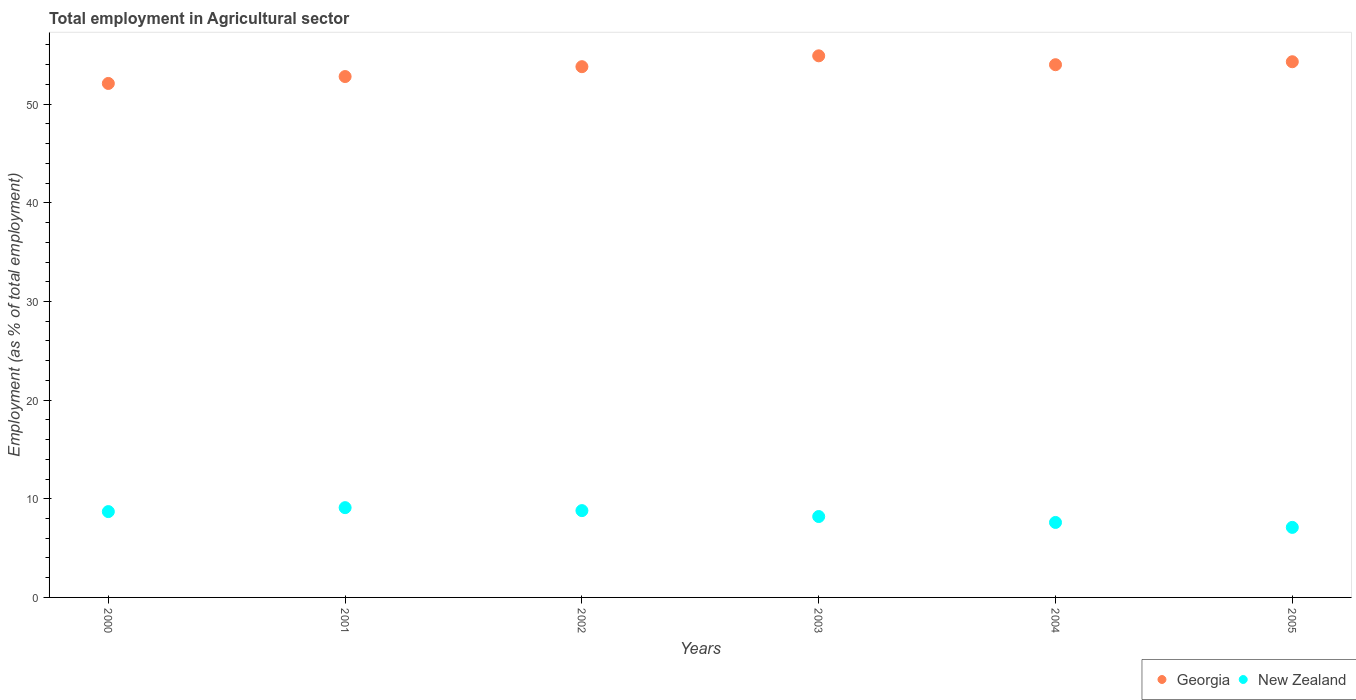How many different coloured dotlines are there?
Offer a very short reply. 2. What is the employment in agricultural sector in Georgia in 2004?
Keep it short and to the point. 54. Across all years, what is the maximum employment in agricultural sector in New Zealand?
Keep it short and to the point. 9.1. Across all years, what is the minimum employment in agricultural sector in Georgia?
Ensure brevity in your answer.  52.1. What is the total employment in agricultural sector in Georgia in the graph?
Your response must be concise. 321.9. What is the difference between the employment in agricultural sector in New Zealand in 2000 and that in 2005?
Make the answer very short. 1.6. What is the difference between the employment in agricultural sector in New Zealand in 2003 and the employment in agricultural sector in Georgia in 2001?
Offer a very short reply. -44.6. What is the average employment in agricultural sector in New Zealand per year?
Provide a succinct answer. 8.25. In the year 2000, what is the difference between the employment in agricultural sector in Georgia and employment in agricultural sector in New Zealand?
Keep it short and to the point. 43.4. What is the ratio of the employment in agricultural sector in New Zealand in 2000 to that in 2005?
Your response must be concise. 1.23. What is the difference between the highest and the second highest employment in agricultural sector in New Zealand?
Provide a succinct answer. 0.3. What is the difference between the highest and the lowest employment in agricultural sector in New Zealand?
Ensure brevity in your answer.  2. In how many years, is the employment in agricultural sector in New Zealand greater than the average employment in agricultural sector in New Zealand taken over all years?
Keep it short and to the point. 3. Is the sum of the employment in agricultural sector in Georgia in 2002 and 2003 greater than the maximum employment in agricultural sector in New Zealand across all years?
Keep it short and to the point. Yes. Does the employment in agricultural sector in Georgia monotonically increase over the years?
Your answer should be very brief. No. Is the employment in agricultural sector in Georgia strictly greater than the employment in agricultural sector in New Zealand over the years?
Ensure brevity in your answer.  Yes. Is the employment in agricultural sector in Georgia strictly less than the employment in agricultural sector in New Zealand over the years?
Keep it short and to the point. No. How many dotlines are there?
Your answer should be compact. 2. What is the difference between two consecutive major ticks on the Y-axis?
Your answer should be very brief. 10. Does the graph contain any zero values?
Make the answer very short. No. How are the legend labels stacked?
Make the answer very short. Horizontal. What is the title of the graph?
Ensure brevity in your answer.  Total employment in Agricultural sector. What is the label or title of the X-axis?
Offer a very short reply. Years. What is the label or title of the Y-axis?
Provide a succinct answer. Employment (as % of total employment). What is the Employment (as % of total employment) in Georgia in 2000?
Your answer should be compact. 52.1. What is the Employment (as % of total employment) of New Zealand in 2000?
Ensure brevity in your answer.  8.7. What is the Employment (as % of total employment) in Georgia in 2001?
Give a very brief answer. 52.8. What is the Employment (as % of total employment) of New Zealand in 2001?
Offer a terse response. 9.1. What is the Employment (as % of total employment) of Georgia in 2002?
Make the answer very short. 53.8. What is the Employment (as % of total employment) in New Zealand in 2002?
Ensure brevity in your answer.  8.8. What is the Employment (as % of total employment) in Georgia in 2003?
Offer a terse response. 54.9. What is the Employment (as % of total employment) of New Zealand in 2003?
Give a very brief answer. 8.2. What is the Employment (as % of total employment) in Georgia in 2004?
Offer a very short reply. 54. What is the Employment (as % of total employment) in New Zealand in 2004?
Your answer should be compact. 7.6. What is the Employment (as % of total employment) of Georgia in 2005?
Provide a short and direct response. 54.3. What is the Employment (as % of total employment) of New Zealand in 2005?
Offer a terse response. 7.1. Across all years, what is the maximum Employment (as % of total employment) in Georgia?
Give a very brief answer. 54.9. Across all years, what is the maximum Employment (as % of total employment) of New Zealand?
Offer a very short reply. 9.1. Across all years, what is the minimum Employment (as % of total employment) in Georgia?
Ensure brevity in your answer.  52.1. Across all years, what is the minimum Employment (as % of total employment) of New Zealand?
Offer a very short reply. 7.1. What is the total Employment (as % of total employment) of Georgia in the graph?
Your answer should be very brief. 321.9. What is the total Employment (as % of total employment) in New Zealand in the graph?
Provide a short and direct response. 49.5. What is the difference between the Employment (as % of total employment) of Georgia in 2000 and that in 2001?
Provide a short and direct response. -0.7. What is the difference between the Employment (as % of total employment) in New Zealand in 2000 and that in 2001?
Your answer should be compact. -0.4. What is the difference between the Employment (as % of total employment) in Georgia in 2000 and that in 2002?
Your response must be concise. -1.7. What is the difference between the Employment (as % of total employment) in Georgia in 2000 and that in 2004?
Ensure brevity in your answer.  -1.9. What is the difference between the Employment (as % of total employment) of New Zealand in 2000 and that in 2004?
Your answer should be compact. 1.1. What is the difference between the Employment (as % of total employment) in Georgia in 2000 and that in 2005?
Ensure brevity in your answer.  -2.2. What is the difference between the Employment (as % of total employment) in Georgia in 2001 and that in 2002?
Provide a succinct answer. -1. What is the difference between the Employment (as % of total employment) in Georgia in 2001 and that in 2003?
Give a very brief answer. -2.1. What is the difference between the Employment (as % of total employment) in New Zealand in 2001 and that in 2005?
Provide a succinct answer. 2. What is the difference between the Employment (as % of total employment) of Georgia in 2002 and that in 2003?
Ensure brevity in your answer.  -1.1. What is the difference between the Employment (as % of total employment) in New Zealand in 2002 and that in 2004?
Offer a very short reply. 1.2. What is the difference between the Employment (as % of total employment) in New Zealand in 2003 and that in 2004?
Keep it short and to the point. 0.6. What is the difference between the Employment (as % of total employment) in Georgia in 2004 and that in 2005?
Give a very brief answer. -0.3. What is the difference between the Employment (as % of total employment) of Georgia in 2000 and the Employment (as % of total employment) of New Zealand in 2001?
Provide a short and direct response. 43. What is the difference between the Employment (as % of total employment) in Georgia in 2000 and the Employment (as % of total employment) in New Zealand in 2002?
Ensure brevity in your answer.  43.3. What is the difference between the Employment (as % of total employment) in Georgia in 2000 and the Employment (as % of total employment) in New Zealand in 2003?
Give a very brief answer. 43.9. What is the difference between the Employment (as % of total employment) of Georgia in 2000 and the Employment (as % of total employment) of New Zealand in 2004?
Offer a terse response. 44.5. What is the difference between the Employment (as % of total employment) in Georgia in 2000 and the Employment (as % of total employment) in New Zealand in 2005?
Keep it short and to the point. 45. What is the difference between the Employment (as % of total employment) of Georgia in 2001 and the Employment (as % of total employment) of New Zealand in 2003?
Your answer should be very brief. 44.6. What is the difference between the Employment (as % of total employment) in Georgia in 2001 and the Employment (as % of total employment) in New Zealand in 2004?
Provide a succinct answer. 45.2. What is the difference between the Employment (as % of total employment) of Georgia in 2001 and the Employment (as % of total employment) of New Zealand in 2005?
Keep it short and to the point. 45.7. What is the difference between the Employment (as % of total employment) in Georgia in 2002 and the Employment (as % of total employment) in New Zealand in 2003?
Provide a short and direct response. 45.6. What is the difference between the Employment (as % of total employment) of Georgia in 2002 and the Employment (as % of total employment) of New Zealand in 2004?
Provide a succinct answer. 46.2. What is the difference between the Employment (as % of total employment) of Georgia in 2002 and the Employment (as % of total employment) of New Zealand in 2005?
Offer a very short reply. 46.7. What is the difference between the Employment (as % of total employment) of Georgia in 2003 and the Employment (as % of total employment) of New Zealand in 2004?
Offer a very short reply. 47.3. What is the difference between the Employment (as % of total employment) in Georgia in 2003 and the Employment (as % of total employment) in New Zealand in 2005?
Ensure brevity in your answer.  47.8. What is the difference between the Employment (as % of total employment) of Georgia in 2004 and the Employment (as % of total employment) of New Zealand in 2005?
Offer a very short reply. 46.9. What is the average Employment (as % of total employment) of Georgia per year?
Offer a terse response. 53.65. What is the average Employment (as % of total employment) of New Zealand per year?
Ensure brevity in your answer.  8.25. In the year 2000, what is the difference between the Employment (as % of total employment) of Georgia and Employment (as % of total employment) of New Zealand?
Your answer should be very brief. 43.4. In the year 2001, what is the difference between the Employment (as % of total employment) of Georgia and Employment (as % of total employment) of New Zealand?
Provide a short and direct response. 43.7. In the year 2003, what is the difference between the Employment (as % of total employment) in Georgia and Employment (as % of total employment) in New Zealand?
Your answer should be very brief. 46.7. In the year 2004, what is the difference between the Employment (as % of total employment) of Georgia and Employment (as % of total employment) of New Zealand?
Offer a very short reply. 46.4. In the year 2005, what is the difference between the Employment (as % of total employment) of Georgia and Employment (as % of total employment) of New Zealand?
Ensure brevity in your answer.  47.2. What is the ratio of the Employment (as % of total employment) in Georgia in 2000 to that in 2001?
Provide a short and direct response. 0.99. What is the ratio of the Employment (as % of total employment) of New Zealand in 2000 to that in 2001?
Provide a succinct answer. 0.96. What is the ratio of the Employment (as % of total employment) in Georgia in 2000 to that in 2002?
Your answer should be very brief. 0.97. What is the ratio of the Employment (as % of total employment) in New Zealand in 2000 to that in 2002?
Make the answer very short. 0.99. What is the ratio of the Employment (as % of total employment) in Georgia in 2000 to that in 2003?
Make the answer very short. 0.95. What is the ratio of the Employment (as % of total employment) of New Zealand in 2000 to that in 2003?
Ensure brevity in your answer.  1.06. What is the ratio of the Employment (as % of total employment) in Georgia in 2000 to that in 2004?
Give a very brief answer. 0.96. What is the ratio of the Employment (as % of total employment) in New Zealand in 2000 to that in 2004?
Your response must be concise. 1.14. What is the ratio of the Employment (as % of total employment) in Georgia in 2000 to that in 2005?
Your answer should be compact. 0.96. What is the ratio of the Employment (as % of total employment) of New Zealand in 2000 to that in 2005?
Keep it short and to the point. 1.23. What is the ratio of the Employment (as % of total employment) of Georgia in 2001 to that in 2002?
Your answer should be compact. 0.98. What is the ratio of the Employment (as % of total employment) of New Zealand in 2001 to that in 2002?
Give a very brief answer. 1.03. What is the ratio of the Employment (as % of total employment) of Georgia in 2001 to that in 2003?
Provide a succinct answer. 0.96. What is the ratio of the Employment (as % of total employment) in New Zealand in 2001 to that in 2003?
Provide a short and direct response. 1.11. What is the ratio of the Employment (as % of total employment) of Georgia in 2001 to that in 2004?
Provide a succinct answer. 0.98. What is the ratio of the Employment (as % of total employment) of New Zealand in 2001 to that in 2004?
Ensure brevity in your answer.  1.2. What is the ratio of the Employment (as % of total employment) of Georgia in 2001 to that in 2005?
Ensure brevity in your answer.  0.97. What is the ratio of the Employment (as % of total employment) of New Zealand in 2001 to that in 2005?
Provide a succinct answer. 1.28. What is the ratio of the Employment (as % of total employment) of Georgia in 2002 to that in 2003?
Ensure brevity in your answer.  0.98. What is the ratio of the Employment (as % of total employment) in New Zealand in 2002 to that in 2003?
Give a very brief answer. 1.07. What is the ratio of the Employment (as % of total employment) of New Zealand in 2002 to that in 2004?
Your answer should be compact. 1.16. What is the ratio of the Employment (as % of total employment) of Georgia in 2002 to that in 2005?
Your answer should be very brief. 0.99. What is the ratio of the Employment (as % of total employment) of New Zealand in 2002 to that in 2005?
Ensure brevity in your answer.  1.24. What is the ratio of the Employment (as % of total employment) of Georgia in 2003 to that in 2004?
Offer a terse response. 1.02. What is the ratio of the Employment (as % of total employment) in New Zealand in 2003 to that in 2004?
Ensure brevity in your answer.  1.08. What is the ratio of the Employment (as % of total employment) in New Zealand in 2003 to that in 2005?
Provide a short and direct response. 1.15. What is the ratio of the Employment (as % of total employment) in Georgia in 2004 to that in 2005?
Make the answer very short. 0.99. What is the ratio of the Employment (as % of total employment) in New Zealand in 2004 to that in 2005?
Offer a terse response. 1.07. 